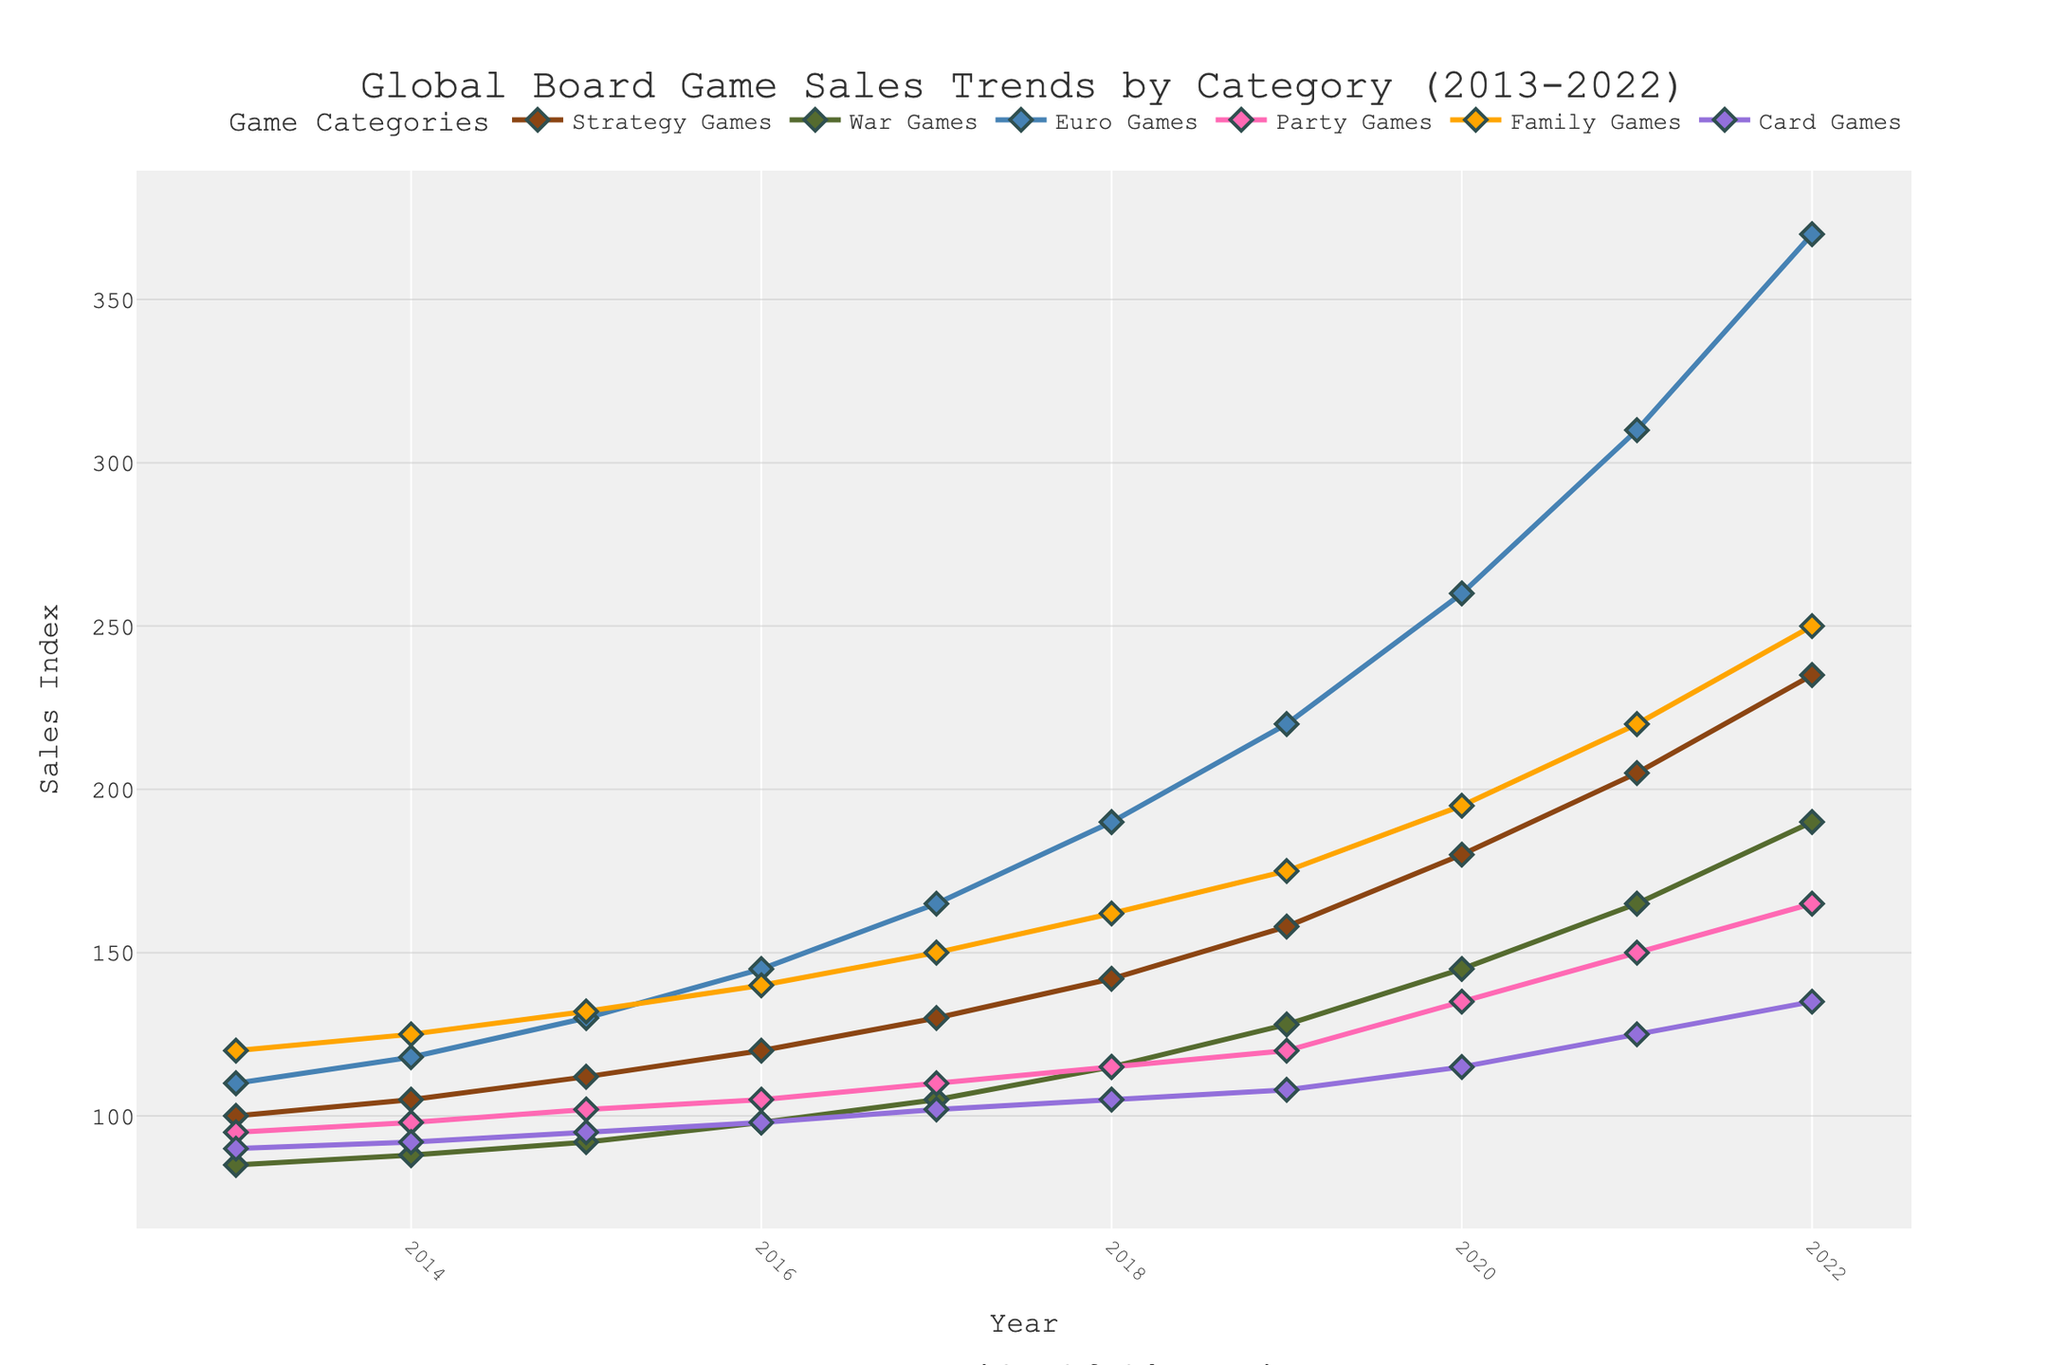What's the trend in sales for Strategy Games over the past decade? To identify the trend for Strategy Games, observe the line representing this category on the graph. The line shows a consistent upward trend from 2013 to 2022. In 2013, sales started at 100 units and reached 235 units by 2022.
Answer: Upward Which category had the highest sales in 2022? Locate the data points for each category in 2022 on the graph. Compare these values and see which one is the highest. Euro Games had the highest sales with a value of 370 units in 2022.
Answer: Euro Games Between which years did War Games see the largest increase in sales? Identify the data points for War Games from year to year and calculate the differences. The largest increase occurred between 2020 (145 units) and 2021 (165 units), with an increase of 20 units.
Answer: 2020-2021 What is the difference in sales between Family Games and Party Games in 2018? Locate the data points for Family Games and Party Games in 2018 on the graph. Family Games have sales of 162 units, and Party Games have 115 units. The difference is \(162 - 115 = 47\) units.
Answer: 47 units How did the sales for Card Games change from 2013 to 2022? Observe the data points for Card Games in 2013 (90 units) and 2022 (135 units). The change is \(135 - 90 = 45\) units, indicating an overall increase in sales.
Answer: Increased by 45 units Which categories' sales converged around 2014? Look at the lines for all categories in 2014 to see if any of them are close together. Strategy Games (105 units), War Games (88 units), Party Games (98 units), and Card Games (92 units) have sales values that are relatively close to each other.
Answer: Strategy Games, War Games, Party Games, and Card Games What was the average sales index of Euro Games from 2020 to 2022? Determine the sales for Euro Games for 2020 (260 units), 2021 (310 units), and 2022 (370 units). Then calculate the average: \((260 + 310 + 370) / 3 = 940 / 3 \approx 313.33\).
Answer: 313.33 units Which category showed the most consistent growth throughout the decade? Compare the lines for each category on the graph. Strategy Games show a steady increase year over year without any significant dips or sudden surge.
Answer: Strategy Games 